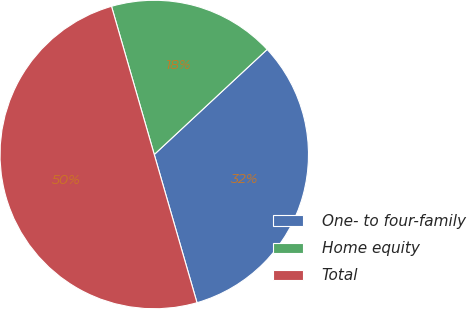Convert chart to OTSL. <chart><loc_0><loc_0><loc_500><loc_500><pie_chart><fcel>One- to four-family<fcel>Home equity<fcel>Total<nl><fcel>32.46%<fcel>17.54%<fcel>50.0%<nl></chart> 